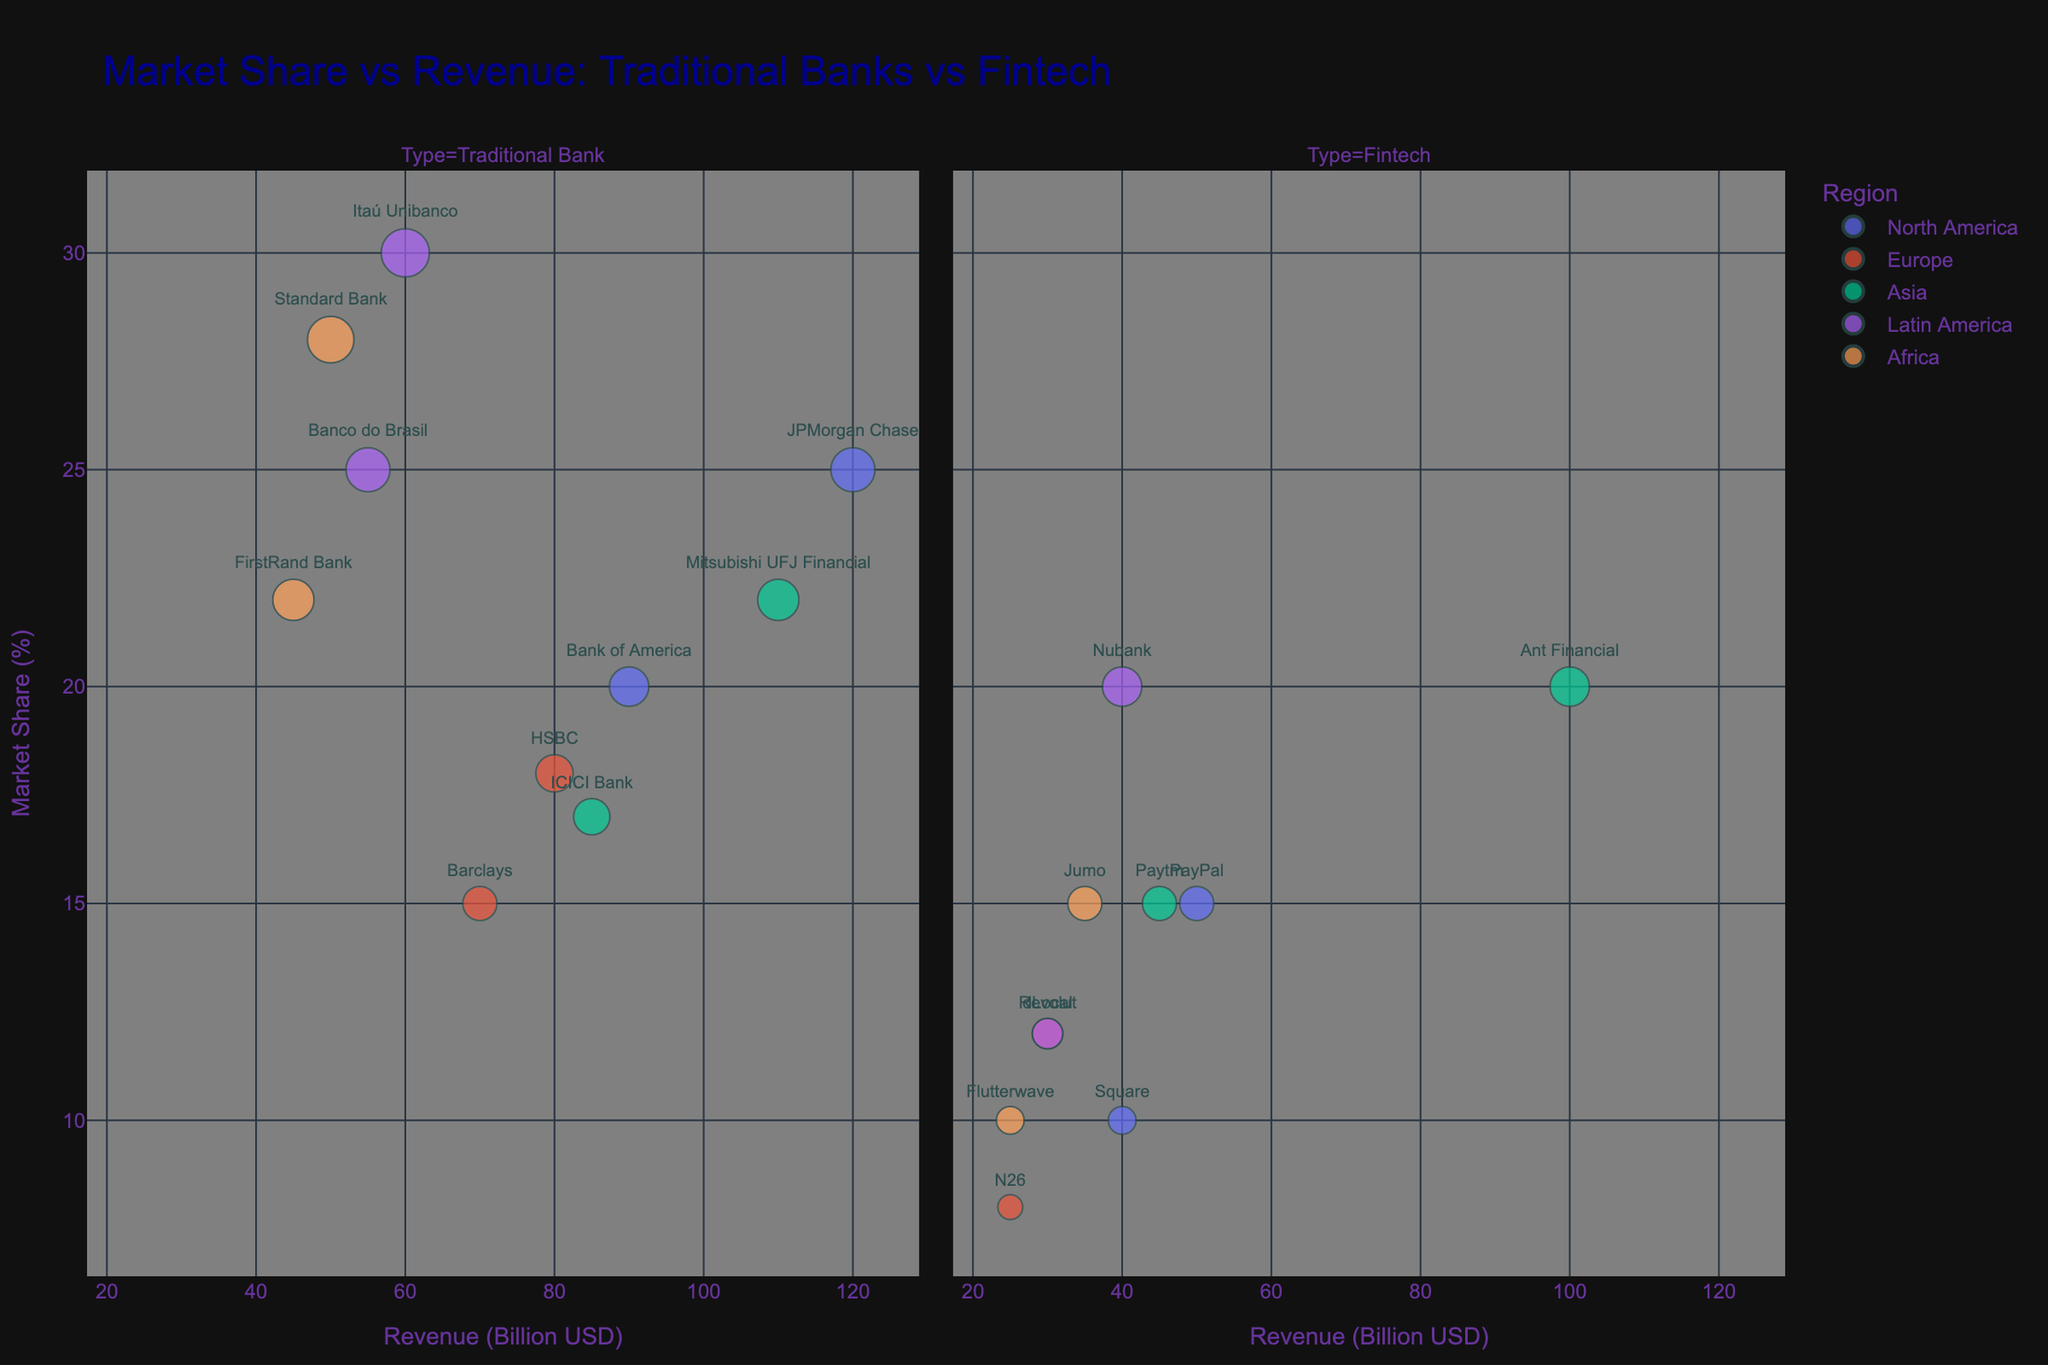How many entities are represented in the North America region? The North America region has 4 entities: 2 traditional banks (JPMorgan Chase, Bank of America) and 2 fintech companies (PayPal, Square).
Answer: 4 What's the average market share of traditional banks in Europe? The traditional banks in Europe are HSBC (18%) and Barclays (15%). The average is calculated as (18 + 15) / 2 = 16.5%.
Answer: 16.5% Which entity has the highest revenue in Asia and what is the value? Look at the bubbles in the 'Asia' facet and check their revenue on the x-axis. Mitsubishi UFJ Financial has the highest revenue of 110 billion USD.
Answer: Mitsubishi UFJ Financial, 110 Who has a higher market share, Standard Bank in Africa or Nubank in Latin America? Compare the Market Share (%) on the y-axis. Standard Bank in Africa has 28%, while Nubank in Latin America has 20%.
Answer: Standard Bank What's the combined market share of fintech companies in North America? Sum up the market shares of PayPal (15%) and Square (10%) in North America: 15 + 10 = 25%.
Answer: 25 Are there more traditional banks or fintech companies represented in the chart? Count the number of entities under each type. There are 10 traditional banks and 8 fintech companies.
Answer: Traditional banks In which region do fintech companies have the highest total revenue? Compare the total revenue of fintech companies across regions. In Asia, Ant Financial (100B) + Paytm (45B) = 145B, which is the highest.
Answer: Asia Which entity type occupies a larger market share in Latin America, traditional banks or fintech companies? Compare the sum of market shares: Traditional banks (Itaú Unibanco 30% + Banco do Brasil 25% = 55%), Fintech (Nubank 20% + dLocal 12% = 32%). Traditional banks have a larger market share.
Answer: Traditional banks What is the smallest bubble size in the Europe region representing, and which entity does it belong to? The smallest bubble can be identified by size. In Europe, this is 8% market share representing N26.
Answer: N26 How does the market share of JPMorgan Chase compare to PayPal? Look at their Market Share (%) on the y-axis. JPMorgan Chase has 25%, while PayPal has 15%.
Answer: JPMorgan Chase has higher market share 